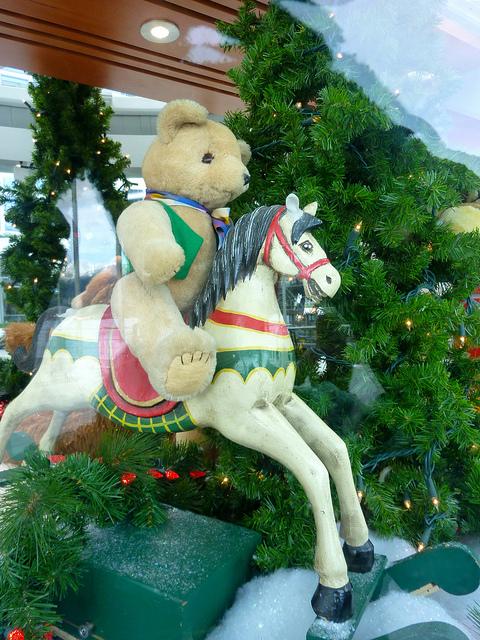Is the horse real?
Keep it brief. No. What time of year is it?
Concise answer only. Christmas. Are these lights on the tree?
Write a very short answer. Yes. 